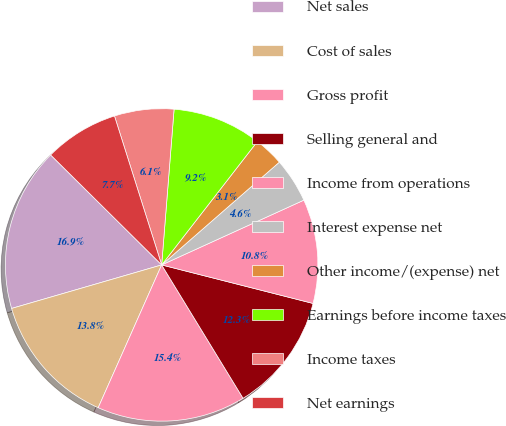<chart> <loc_0><loc_0><loc_500><loc_500><pie_chart><fcel>Net sales<fcel>Cost of sales<fcel>Gross profit<fcel>Selling general and<fcel>Income from operations<fcel>Interest expense net<fcel>Other income/(expense) net<fcel>Earnings before income taxes<fcel>Income taxes<fcel>Net earnings<nl><fcel>16.92%<fcel>13.85%<fcel>15.38%<fcel>12.31%<fcel>10.77%<fcel>4.62%<fcel>3.08%<fcel>9.23%<fcel>6.15%<fcel>7.69%<nl></chart> 